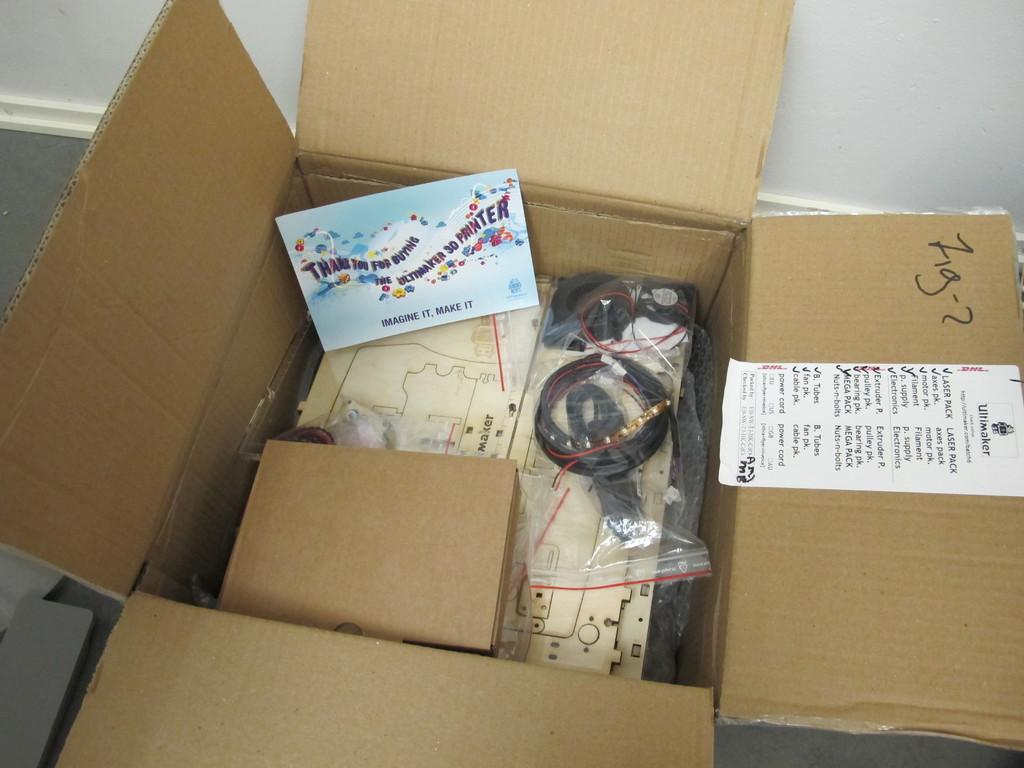<image>
Write a terse but informative summary of the picture. The inner flap of an opened box indicates it is from Ultimaker and contains a laser pack. 